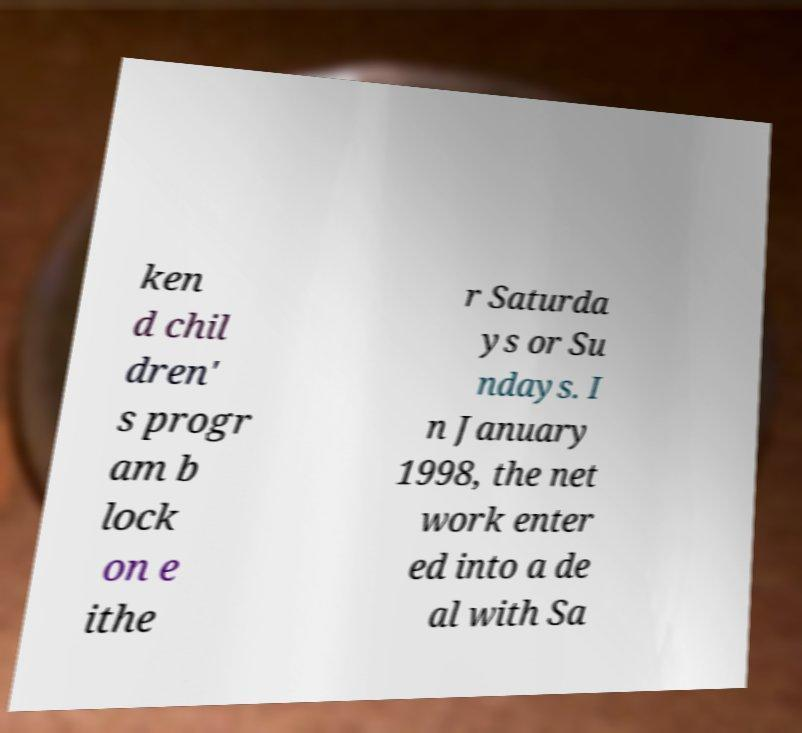Could you assist in decoding the text presented in this image and type it out clearly? ken d chil dren' s progr am b lock on e ithe r Saturda ys or Su ndays. I n January 1998, the net work enter ed into a de al with Sa 